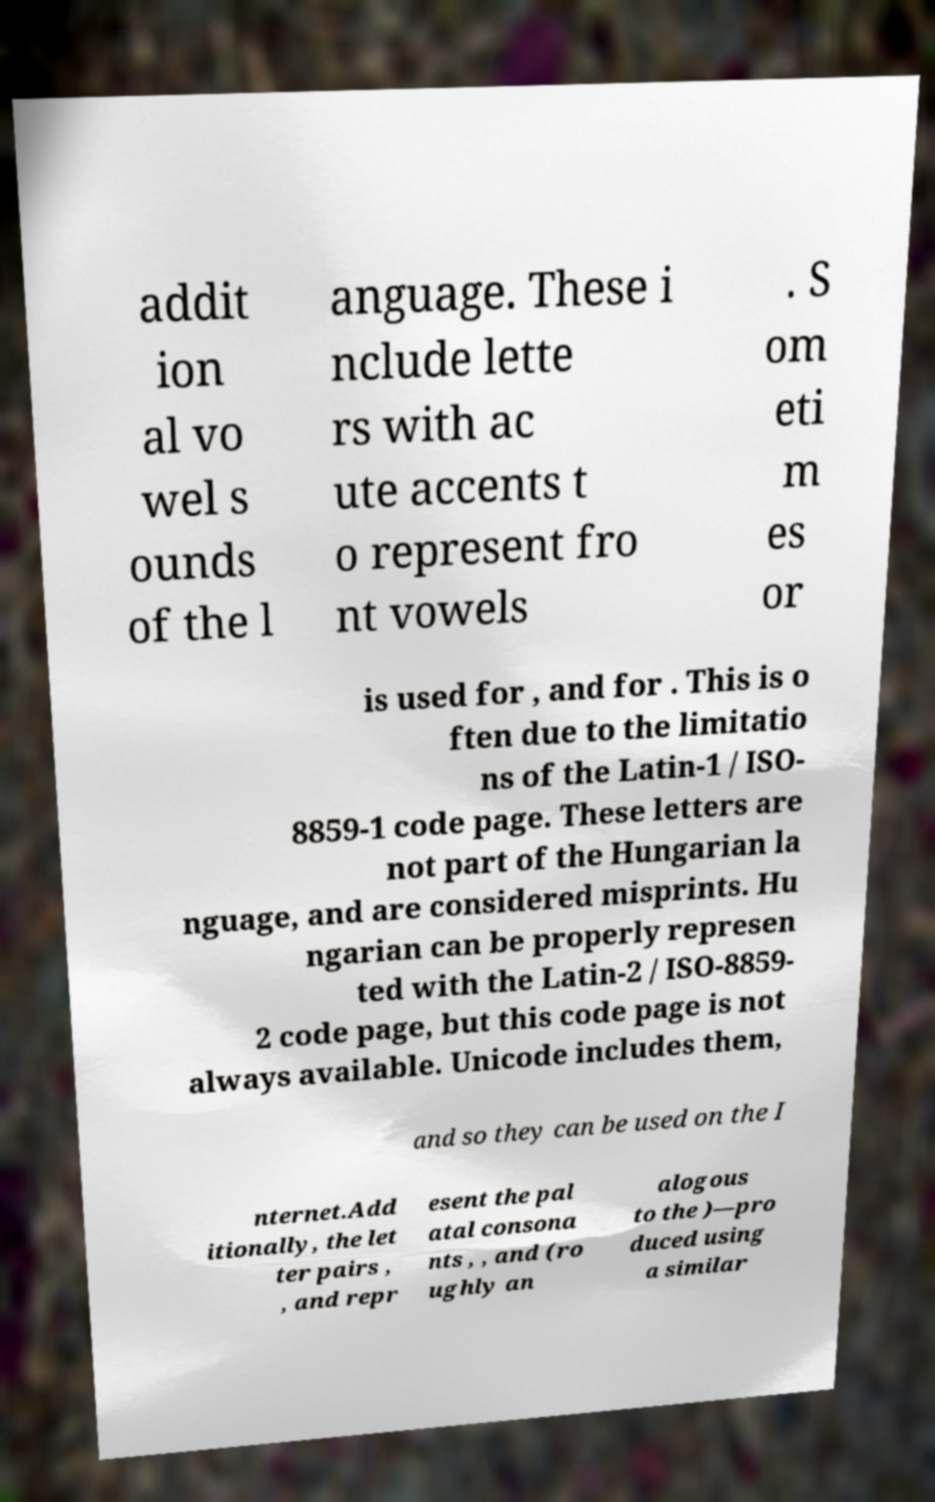Could you extract and type out the text from this image? addit ion al vo wel s ounds of the l anguage. These i nclude lette rs with ac ute accents t o represent fro nt vowels . S om eti m es or is used for , and for . This is o ften due to the limitatio ns of the Latin-1 / ISO- 8859-1 code page. These letters are not part of the Hungarian la nguage, and are considered misprints. Hu ngarian can be properly represen ted with the Latin-2 / ISO-8859- 2 code page, but this code page is not always available. Unicode includes them, and so they can be used on the I nternet.Add itionally, the let ter pairs , , and repr esent the pal atal consona nts , , and (ro ughly an alogous to the )—pro duced using a similar 